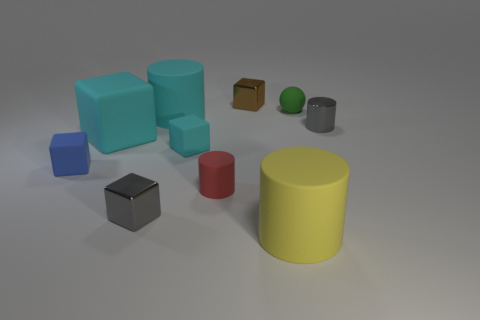Subtract all tiny cyan matte cubes. How many cubes are left? 4 Subtract all brown blocks. How many blocks are left? 4 Subtract all purple blocks. Subtract all brown cylinders. How many blocks are left? 5 Subtract all cylinders. How many objects are left? 6 Add 1 small gray metal objects. How many small gray metal objects are left? 3 Add 5 big yellow rubber objects. How many big yellow rubber objects exist? 6 Subtract 0 blue cylinders. How many objects are left? 10 Subtract all gray blocks. Subtract all rubber cylinders. How many objects are left? 6 